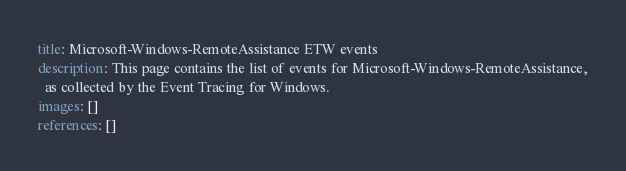<code> <loc_0><loc_0><loc_500><loc_500><_YAML_>title: Microsoft-Windows-RemoteAssistance ETW events
description: This page contains the list of events for Microsoft-Windows-RemoteAssistance,
  as collected by the Event Tracing for Windows.
images: []
references: []
</code> 